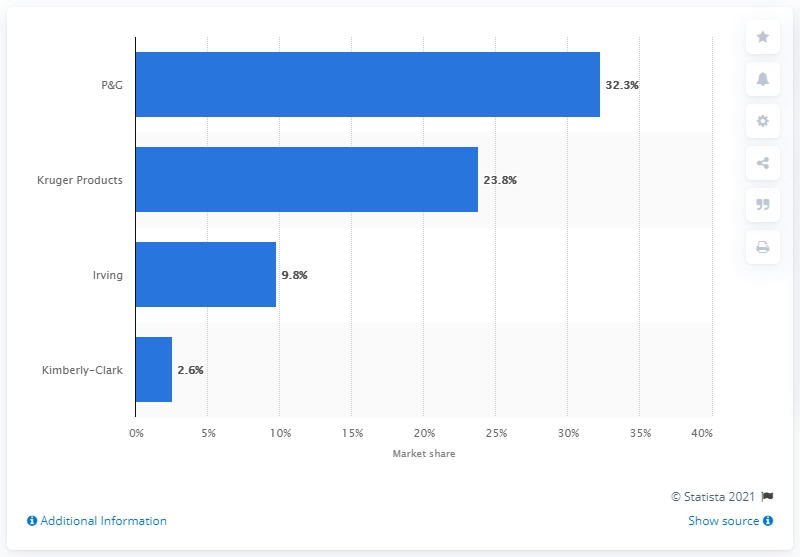Mention a couple of crucial points in this snapshot. In September 2016, Procter & Gamble's market share of paper towels in Canada was 32.3%. 